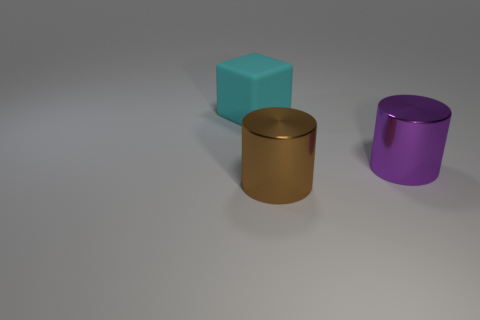Is there anything else that has the same material as the large block?
Ensure brevity in your answer.  No. What shape is the thing on the right side of the big shiny object on the left side of the big thing right of the large brown metal thing?
Give a very brief answer. Cylinder. The cyan thing is what size?
Offer a terse response. Large. Is there a tiny yellow cylinder that has the same material as the cyan block?
Make the answer very short. No. The brown metal thing that is the same shape as the big purple metallic object is what size?
Make the answer very short. Large. Are there an equal number of big cylinders that are on the left side of the big brown shiny thing and matte things?
Your answer should be very brief. No. There is a thing behind the purple metal object; is its shape the same as the purple object?
Offer a very short reply. No. What is the shape of the cyan rubber object?
Offer a very short reply. Cube. There is a large cylinder on the left side of the big shiny thing behind the object that is in front of the big purple thing; what is it made of?
Give a very brief answer. Metal. How many things are brown metal objects or large green balls?
Your response must be concise. 1. 